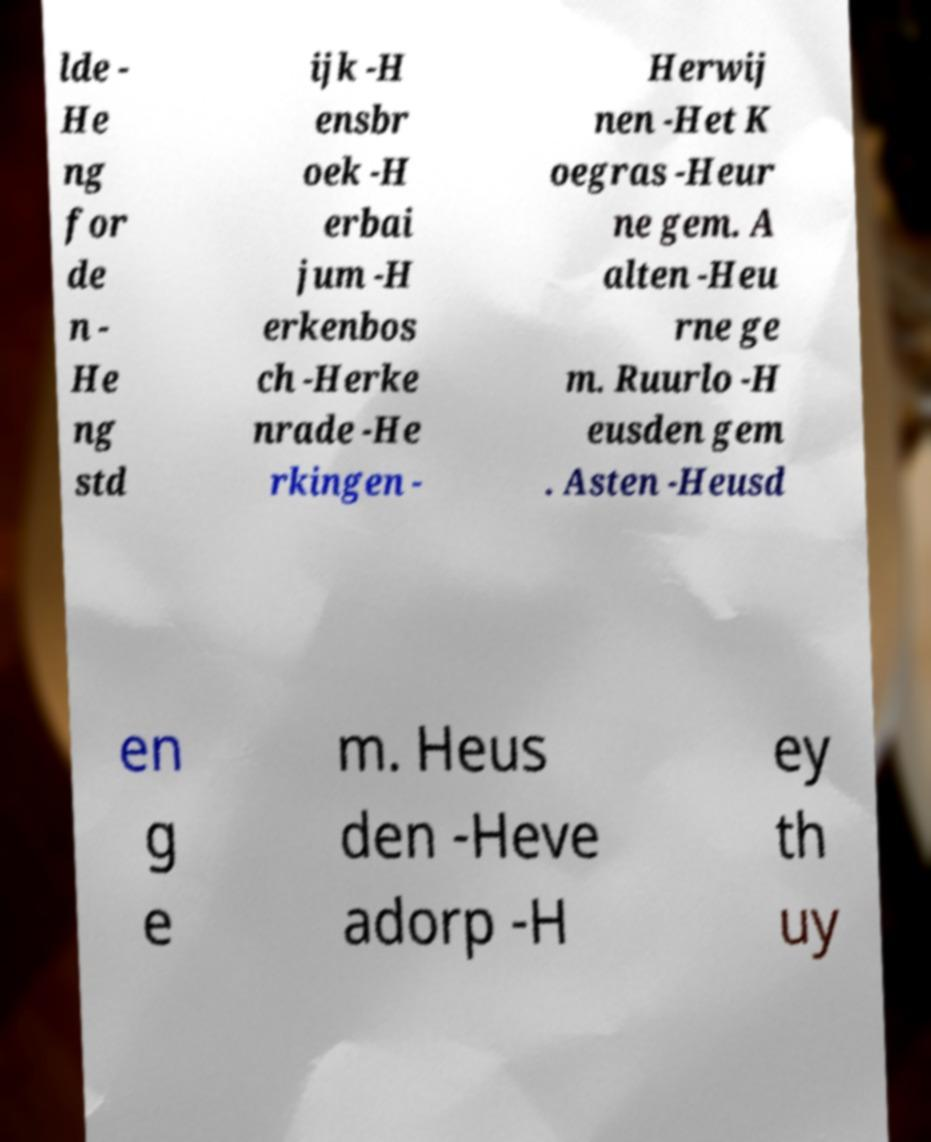What messages or text are displayed in this image? I need them in a readable, typed format. lde - He ng for de n - He ng std ijk -H ensbr oek -H erbai jum -H erkenbos ch -Herke nrade -He rkingen - Herwij nen -Het K oegras -Heur ne gem. A alten -Heu rne ge m. Ruurlo -H eusden gem . Asten -Heusd en g e m. Heus den -Heve adorp -H ey th uy 